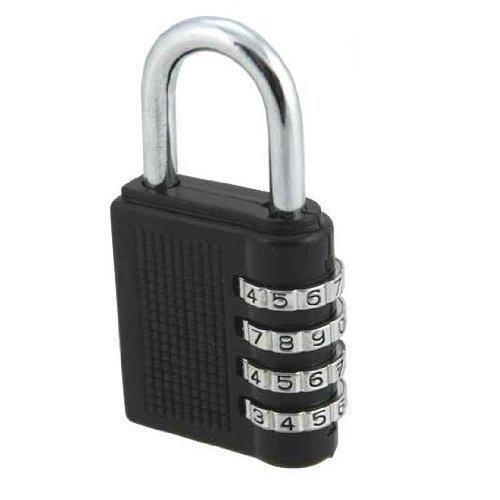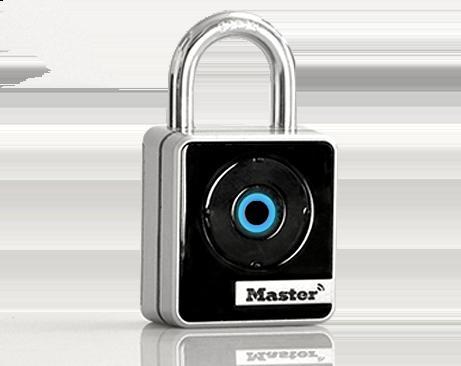The first image is the image on the left, the second image is the image on the right. Considering the images on both sides, is "There are at least three padlocks." valid? Answer yes or no. No. The first image is the image on the left, the second image is the image on the right. Examine the images to the left and right. Is the description "There are two locks." accurate? Answer yes or no. Yes. 